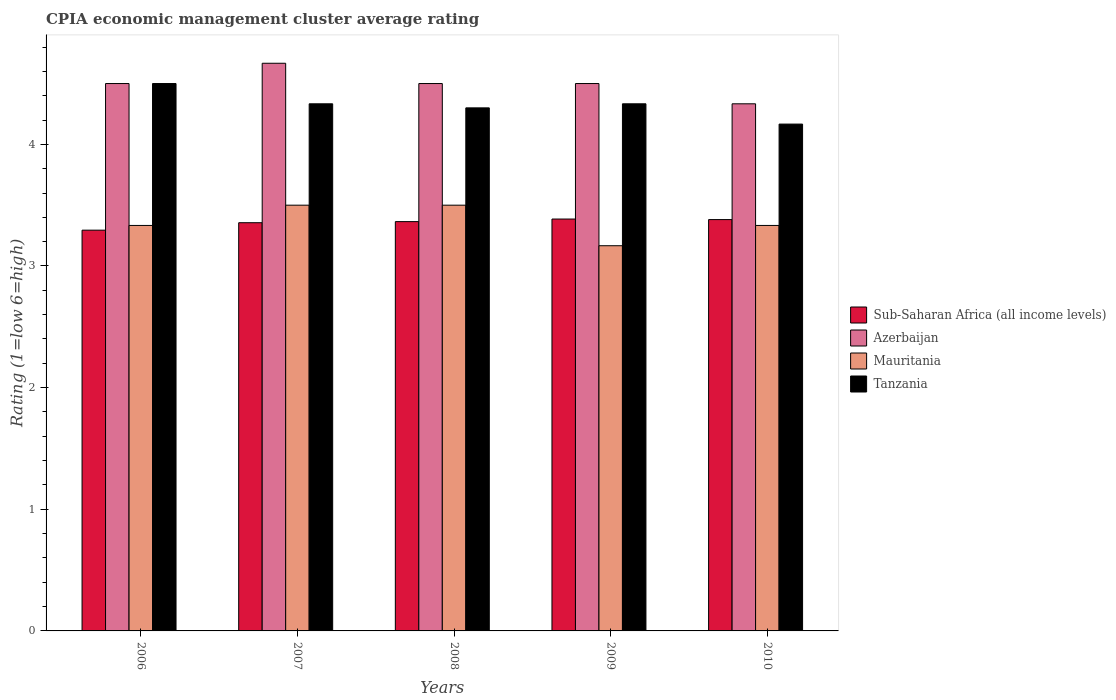How many groups of bars are there?
Ensure brevity in your answer.  5. Are the number of bars per tick equal to the number of legend labels?
Make the answer very short. Yes. How many bars are there on the 5th tick from the right?
Your response must be concise. 4. What is the label of the 5th group of bars from the left?
Make the answer very short. 2010. What is the CPIA rating in Sub-Saharan Africa (all income levels) in 2006?
Offer a terse response. 3.29. Across all years, what is the maximum CPIA rating in Mauritania?
Make the answer very short. 3.5. Across all years, what is the minimum CPIA rating in Mauritania?
Provide a succinct answer. 3.17. In which year was the CPIA rating in Mauritania maximum?
Keep it short and to the point. 2007. In which year was the CPIA rating in Azerbaijan minimum?
Your response must be concise. 2010. What is the total CPIA rating in Mauritania in the graph?
Offer a terse response. 16.83. What is the difference between the CPIA rating in Tanzania in 2006 and that in 2007?
Keep it short and to the point. 0.17. What is the difference between the CPIA rating in Tanzania in 2007 and the CPIA rating in Sub-Saharan Africa (all income levels) in 2008?
Give a very brief answer. 0.97. In the year 2009, what is the difference between the CPIA rating in Azerbaijan and CPIA rating in Tanzania?
Offer a very short reply. 0.17. In how many years, is the CPIA rating in Mauritania greater than 3.2?
Keep it short and to the point. 4. What is the ratio of the CPIA rating in Mauritania in 2007 to that in 2008?
Make the answer very short. 1. Is the CPIA rating in Azerbaijan in 2007 less than that in 2010?
Make the answer very short. No. What is the difference between the highest and the second highest CPIA rating in Tanzania?
Your response must be concise. 0.17. What is the difference between the highest and the lowest CPIA rating in Tanzania?
Provide a succinct answer. 0.33. What does the 1st bar from the left in 2007 represents?
Make the answer very short. Sub-Saharan Africa (all income levels). What does the 4th bar from the right in 2007 represents?
Your response must be concise. Sub-Saharan Africa (all income levels). How many bars are there?
Provide a short and direct response. 20. Are all the bars in the graph horizontal?
Make the answer very short. No. What is the difference between two consecutive major ticks on the Y-axis?
Offer a terse response. 1. Are the values on the major ticks of Y-axis written in scientific E-notation?
Provide a short and direct response. No. How are the legend labels stacked?
Ensure brevity in your answer.  Vertical. What is the title of the graph?
Make the answer very short. CPIA economic management cluster average rating. What is the label or title of the X-axis?
Provide a succinct answer. Years. What is the Rating (1=low 6=high) in Sub-Saharan Africa (all income levels) in 2006?
Provide a short and direct response. 3.29. What is the Rating (1=low 6=high) of Azerbaijan in 2006?
Keep it short and to the point. 4.5. What is the Rating (1=low 6=high) of Mauritania in 2006?
Give a very brief answer. 3.33. What is the Rating (1=low 6=high) of Sub-Saharan Africa (all income levels) in 2007?
Keep it short and to the point. 3.36. What is the Rating (1=low 6=high) in Azerbaijan in 2007?
Offer a very short reply. 4.67. What is the Rating (1=low 6=high) in Mauritania in 2007?
Your response must be concise. 3.5. What is the Rating (1=low 6=high) in Tanzania in 2007?
Keep it short and to the point. 4.33. What is the Rating (1=low 6=high) in Sub-Saharan Africa (all income levels) in 2008?
Offer a very short reply. 3.36. What is the Rating (1=low 6=high) of Azerbaijan in 2008?
Make the answer very short. 4.5. What is the Rating (1=low 6=high) of Mauritania in 2008?
Give a very brief answer. 3.5. What is the Rating (1=low 6=high) of Tanzania in 2008?
Offer a very short reply. 4.3. What is the Rating (1=low 6=high) of Sub-Saharan Africa (all income levels) in 2009?
Offer a terse response. 3.39. What is the Rating (1=low 6=high) in Mauritania in 2009?
Provide a succinct answer. 3.17. What is the Rating (1=low 6=high) of Tanzania in 2009?
Your response must be concise. 4.33. What is the Rating (1=low 6=high) in Sub-Saharan Africa (all income levels) in 2010?
Offer a very short reply. 3.38. What is the Rating (1=low 6=high) of Azerbaijan in 2010?
Give a very brief answer. 4.33. What is the Rating (1=low 6=high) in Mauritania in 2010?
Provide a succinct answer. 3.33. What is the Rating (1=low 6=high) in Tanzania in 2010?
Provide a short and direct response. 4.17. Across all years, what is the maximum Rating (1=low 6=high) in Sub-Saharan Africa (all income levels)?
Provide a succinct answer. 3.39. Across all years, what is the maximum Rating (1=low 6=high) of Azerbaijan?
Your answer should be compact. 4.67. Across all years, what is the maximum Rating (1=low 6=high) of Tanzania?
Provide a succinct answer. 4.5. Across all years, what is the minimum Rating (1=low 6=high) of Sub-Saharan Africa (all income levels)?
Your answer should be very brief. 3.29. Across all years, what is the minimum Rating (1=low 6=high) in Azerbaijan?
Make the answer very short. 4.33. Across all years, what is the minimum Rating (1=low 6=high) in Mauritania?
Your answer should be compact. 3.17. Across all years, what is the minimum Rating (1=low 6=high) in Tanzania?
Provide a succinct answer. 4.17. What is the total Rating (1=low 6=high) in Sub-Saharan Africa (all income levels) in the graph?
Offer a terse response. 16.78. What is the total Rating (1=low 6=high) of Azerbaijan in the graph?
Give a very brief answer. 22.5. What is the total Rating (1=low 6=high) of Mauritania in the graph?
Keep it short and to the point. 16.83. What is the total Rating (1=low 6=high) in Tanzania in the graph?
Provide a short and direct response. 21.63. What is the difference between the Rating (1=low 6=high) of Sub-Saharan Africa (all income levels) in 2006 and that in 2007?
Give a very brief answer. -0.06. What is the difference between the Rating (1=low 6=high) of Azerbaijan in 2006 and that in 2007?
Your answer should be compact. -0.17. What is the difference between the Rating (1=low 6=high) in Sub-Saharan Africa (all income levels) in 2006 and that in 2008?
Your response must be concise. -0.07. What is the difference between the Rating (1=low 6=high) of Sub-Saharan Africa (all income levels) in 2006 and that in 2009?
Ensure brevity in your answer.  -0.09. What is the difference between the Rating (1=low 6=high) in Tanzania in 2006 and that in 2009?
Your answer should be very brief. 0.17. What is the difference between the Rating (1=low 6=high) of Sub-Saharan Africa (all income levels) in 2006 and that in 2010?
Provide a short and direct response. -0.09. What is the difference between the Rating (1=low 6=high) in Tanzania in 2006 and that in 2010?
Ensure brevity in your answer.  0.33. What is the difference between the Rating (1=low 6=high) of Sub-Saharan Africa (all income levels) in 2007 and that in 2008?
Keep it short and to the point. -0.01. What is the difference between the Rating (1=low 6=high) in Azerbaijan in 2007 and that in 2008?
Make the answer very short. 0.17. What is the difference between the Rating (1=low 6=high) in Mauritania in 2007 and that in 2008?
Keep it short and to the point. 0. What is the difference between the Rating (1=low 6=high) of Tanzania in 2007 and that in 2008?
Ensure brevity in your answer.  0.03. What is the difference between the Rating (1=low 6=high) of Sub-Saharan Africa (all income levels) in 2007 and that in 2009?
Keep it short and to the point. -0.03. What is the difference between the Rating (1=low 6=high) in Sub-Saharan Africa (all income levels) in 2007 and that in 2010?
Provide a succinct answer. -0.03. What is the difference between the Rating (1=low 6=high) in Azerbaijan in 2007 and that in 2010?
Offer a terse response. 0.33. What is the difference between the Rating (1=low 6=high) of Mauritania in 2007 and that in 2010?
Make the answer very short. 0.17. What is the difference between the Rating (1=low 6=high) of Tanzania in 2007 and that in 2010?
Your answer should be compact. 0.17. What is the difference between the Rating (1=low 6=high) in Sub-Saharan Africa (all income levels) in 2008 and that in 2009?
Your answer should be compact. -0.02. What is the difference between the Rating (1=low 6=high) in Azerbaijan in 2008 and that in 2009?
Ensure brevity in your answer.  0. What is the difference between the Rating (1=low 6=high) of Tanzania in 2008 and that in 2009?
Provide a short and direct response. -0.03. What is the difference between the Rating (1=low 6=high) in Sub-Saharan Africa (all income levels) in 2008 and that in 2010?
Offer a terse response. -0.02. What is the difference between the Rating (1=low 6=high) in Tanzania in 2008 and that in 2010?
Your answer should be very brief. 0.13. What is the difference between the Rating (1=low 6=high) of Sub-Saharan Africa (all income levels) in 2009 and that in 2010?
Offer a terse response. 0. What is the difference between the Rating (1=low 6=high) in Azerbaijan in 2009 and that in 2010?
Offer a terse response. 0.17. What is the difference between the Rating (1=low 6=high) of Mauritania in 2009 and that in 2010?
Make the answer very short. -0.17. What is the difference between the Rating (1=low 6=high) of Sub-Saharan Africa (all income levels) in 2006 and the Rating (1=low 6=high) of Azerbaijan in 2007?
Your response must be concise. -1.37. What is the difference between the Rating (1=low 6=high) of Sub-Saharan Africa (all income levels) in 2006 and the Rating (1=low 6=high) of Mauritania in 2007?
Your response must be concise. -0.21. What is the difference between the Rating (1=low 6=high) in Sub-Saharan Africa (all income levels) in 2006 and the Rating (1=low 6=high) in Tanzania in 2007?
Your answer should be compact. -1.04. What is the difference between the Rating (1=low 6=high) in Azerbaijan in 2006 and the Rating (1=low 6=high) in Mauritania in 2007?
Your answer should be compact. 1. What is the difference between the Rating (1=low 6=high) in Azerbaijan in 2006 and the Rating (1=low 6=high) in Tanzania in 2007?
Provide a short and direct response. 0.17. What is the difference between the Rating (1=low 6=high) of Mauritania in 2006 and the Rating (1=low 6=high) of Tanzania in 2007?
Keep it short and to the point. -1. What is the difference between the Rating (1=low 6=high) of Sub-Saharan Africa (all income levels) in 2006 and the Rating (1=low 6=high) of Azerbaijan in 2008?
Keep it short and to the point. -1.21. What is the difference between the Rating (1=low 6=high) in Sub-Saharan Africa (all income levels) in 2006 and the Rating (1=low 6=high) in Mauritania in 2008?
Give a very brief answer. -0.21. What is the difference between the Rating (1=low 6=high) in Sub-Saharan Africa (all income levels) in 2006 and the Rating (1=low 6=high) in Tanzania in 2008?
Your response must be concise. -1.01. What is the difference between the Rating (1=low 6=high) in Mauritania in 2006 and the Rating (1=low 6=high) in Tanzania in 2008?
Keep it short and to the point. -0.97. What is the difference between the Rating (1=low 6=high) of Sub-Saharan Africa (all income levels) in 2006 and the Rating (1=low 6=high) of Azerbaijan in 2009?
Your response must be concise. -1.21. What is the difference between the Rating (1=low 6=high) of Sub-Saharan Africa (all income levels) in 2006 and the Rating (1=low 6=high) of Mauritania in 2009?
Make the answer very short. 0.13. What is the difference between the Rating (1=low 6=high) of Sub-Saharan Africa (all income levels) in 2006 and the Rating (1=low 6=high) of Tanzania in 2009?
Provide a short and direct response. -1.04. What is the difference between the Rating (1=low 6=high) in Azerbaijan in 2006 and the Rating (1=low 6=high) in Mauritania in 2009?
Your response must be concise. 1.33. What is the difference between the Rating (1=low 6=high) of Azerbaijan in 2006 and the Rating (1=low 6=high) of Tanzania in 2009?
Make the answer very short. 0.17. What is the difference between the Rating (1=low 6=high) in Sub-Saharan Africa (all income levels) in 2006 and the Rating (1=low 6=high) in Azerbaijan in 2010?
Offer a terse response. -1.04. What is the difference between the Rating (1=low 6=high) of Sub-Saharan Africa (all income levels) in 2006 and the Rating (1=low 6=high) of Mauritania in 2010?
Keep it short and to the point. -0.04. What is the difference between the Rating (1=low 6=high) in Sub-Saharan Africa (all income levels) in 2006 and the Rating (1=low 6=high) in Tanzania in 2010?
Provide a succinct answer. -0.87. What is the difference between the Rating (1=low 6=high) in Azerbaijan in 2006 and the Rating (1=low 6=high) in Mauritania in 2010?
Make the answer very short. 1.17. What is the difference between the Rating (1=low 6=high) in Azerbaijan in 2006 and the Rating (1=low 6=high) in Tanzania in 2010?
Offer a terse response. 0.33. What is the difference between the Rating (1=low 6=high) of Sub-Saharan Africa (all income levels) in 2007 and the Rating (1=low 6=high) of Azerbaijan in 2008?
Ensure brevity in your answer.  -1.14. What is the difference between the Rating (1=low 6=high) in Sub-Saharan Africa (all income levels) in 2007 and the Rating (1=low 6=high) in Mauritania in 2008?
Offer a terse response. -0.14. What is the difference between the Rating (1=low 6=high) of Sub-Saharan Africa (all income levels) in 2007 and the Rating (1=low 6=high) of Tanzania in 2008?
Keep it short and to the point. -0.94. What is the difference between the Rating (1=low 6=high) in Azerbaijan in 2007 and the Rating (1=low 6=high) in Tanzania in 2008?
Give a very brief answer. 0.37. What is the difference between the Rating (1=low 6=high) of Mauritania in 2007 and the Rating (1=low 6=high) of Tanzania in 2008?
Your response must be concise. -0.8. What is the difference between the Rating (1=low 6=high) in Sub-Saharan Africa (all income levels) in 2007 and the Rating (1=low 6=high) in Azerbaijan in 2009?
Offer a very short reply. -1.14. What is the difference between the Rating (1=low 6=high) in Sub-Saharan Africa (all income levels) in 2007 and the Rating (1=low 6=high) in Mauritania in 2009?
Offer a terse response. 0.19. What is the difference between the Rating (1=low 6=high) of Sub-Saharan Africa (all income levels) in 2007 and the Rating (1=low 6=high) of Tanzania in 2009?
Provide a succinct answer. -0.98. What is the difference between the Rating (1=low 6=high) in Sub-Saharan Africa (all income levels) in 2007 and the Rating (1=low 6=high) in Azerbaijan in 2010?
Offer a very short reply. -0.98. What is the difference between the Rating (1=low 6=high) of Sub-Saharan Africa (all income levels) in 2007 and the Rating (1=low 6=high) of Mauritania in 2010?
Offer a very short reply. 0.02. What is the difference between the Rating (1=low 6=high) in Sub-Saharan Africa (all income levels) in 2007 and the Rating (1=low 6=high) in Tanzania in 2010?
Make the answer very short. -0.81. What is the difference between the Rating (1=low 6=high) of Azerbaijan in 2007 and the Rating (1=low 6=high) of Mauritania in 2010?
Make the answer very short. 1.33. What is the difference between the Rating (1=low 6=high) of Sub-Saharan Africa (all income levels) in 2008 and the Rating (1=low 6=high) of Azerbaijan in 2009?
Your answer should be compact. -1.14. What is the difference between the Rating (1=low 6=high) of Sub-Saharan Africa (all income levels) in 2008 and the Rating (1=low 6=high) of Mauritania in 2009?
Keep it short and to the point. 0.2. What is the difference between the Rating (1=low 6=high) of Sub-Saharan Africa (all income levels) in 2008 and the Rating (1=low 6=high) of Tanzania in 2009?
Your response must be concise. -0.97. What is the difference between the Rating (1=low 6=high) of Sub-Saharan Africa (all income levels) in 2008 and the Rating (1=low 6=high) of Azerbaijan in 2010?
Provide a short and direct response. -0.97. What is the difference between the Rating (1=low 6=high) of Sub-Saharan Africa (all income levels) in 2008 and the Rating (1=low 6=high) of Mauritania in 2010?
Offer a very short reply. 0.03. What is the difference between the Rating (1=low 6=high) in Sub-Saharan Africa (all income levels) in 2008 and the Rating (1=low 6=high) in Tanzania in 2010?
Offer a terse response. -0.8. What is the difference between the Rating (1=low 6=high) in Azerbaijan in 2008 and the Rating (1=low 6=high) in Mauritania in 2010?
Keep it short and to the point. 1.17. What is the difference between the Rating (1=low 6=high) in Azerbaijan in 2008 and the Rating (1=low 6=high) in Tanzania in 2010?
Give a very brief answer. 0.33. What is the difference between the Rating (1=low 6=high) in Sub-Saharan Africa (all income levels) in 2009 and the Rating (1=low 6=high) in Azerbaijan in 2010?
Ensure brevity in your answer.  -0.95. What is the difference between the Rating (1=low 6=high) in Sub-Saharan Africa (all income levels) in 2009 and the Rating (1=low 6=high) in Mauritania in 2010?
Your answer should be compact. 0.05. What is the difference between the Rating (1=low 6=high) in Sub-Saharan Africa (all income levels) in 2009 and the Rating (1=low 6=high) in Tanzania in 2010?
Ensure brevity in your answer.  -0.78. What is the difference between the Rating (1=low 6=high) in Azerbaijan in 2009 and the Rating (1=low 6=high) in Mauritania in 2010?
Your answer should be compact. 1.17. What is the difference between the Rating (1=low 6=high) of Azerbaijan in 2009 and the Rating (1=low 6=high) of Tanzania in 2010?
Your response must be concise. 0.33. What is the average Rating (1=low 6=high) of Sub-Saharan Africa (all income levels) per year?
Your answer should be very brief. 3.36. What is the average Rating (1=low 6=high) in Mauritania per year?
Your answer should be compact. 3.37. What is the average Rating (1=low 6=high) of Tanzania per year?
Your answer should be very brief. 4.33. In the year 2006, what is the difference between the Rating (1=low 6=high) in Sub-Saharan Africa (all income levels) and Rating (1=low 6=high) in Azerbaijan?
Provide a succinct answer. -1.21. In the year 2006, what is the difference between the Rating (1=low 6=high) in Sub-Saharan Africa (all income levels) and Rating (1=low 6=high) in Mauritania?
Your answer should be compact. -0.04. In the year 2006, what is the difference between the Rating (1=low 6=high) of Sub-Saharan Africa (all income levels) and Rating (1=low 6=high) of Tanzania?
Your response must be concise. -1.21. In the year 2006, what is the difference between the Rating (1=low 6=high) in Azerbaijan and Rating (1=low 6=high) in Tanzania?
Offer a terse response. 0. In the year 2006, what is the difference between the Rating (1=low 6=high) of Mauritania and Rating (1=low 6=high) of Tanzania?
Offer a very short reply. -1.17. In the year 2007, what is the difference between the Rating (1=low 6=high) in Sub-Saharan Africa (all income levels) and Rating (1=low 6=high) in Azerbaijan?
Offer a very short reply. -1.31. In the year 2007, what is the difference between the Rating (1=low 6=high) of Sub-Saharan Africa (all income levels) and Rating (1=low 6=high) of Mauritania?
Provide a short and direct response. -0.14. In the year 2007, what is the difference between the Rating (1=low 6=high) of Sub-Saharan Africa (all income levels) and Rating (1=low 6=high) of Tanzania?
Provide a short and direct response. -0.98. In the year 2007, what is the difference between the Rating (1=low 6=high) of Mauritania and Rating (1=low 6=high) of Tanzania?
Your answer should be compact. -0.83. In the year 2008, what is the difference between the Rating (1=low 6=high) of Sub-Saharan Africa (all income levels) and Rating (1=low 6=high) of Azerbaijan?
Your response must be concise. -1.14. In the year 2008, what is the difference between the Rating (1=low 6=high) of Sub-Saharan Africa (all income levels) and Rating (1=low 6=high) of Mauritania?
Provide a succinct answer. -0.14. In the year 2008, what is the difference between the Rating (1=low 6=high) in Sub-Saharan Africa (all income levels) and Rating (1=low 6=high) in Tanzania?
Your answer should be very brief. -0.94. In the year 2008, what is the difference between the Rating (1=low 6=high) of Mauritania and Rating (1=low 6=high) of Tanzania?
Provide a short and direct response. -0.8. In the year 2009, what is the difference between the Rating (1=low 6=high) of Sub-Saharan Africa (all income levels) and Rating (1=low 6=high) of Azerbaijan?
Keep it short and to the point. -1.11. In the year 2009, what is the difference between the Rating (1=low 6=high) in Sub-Saharan Africa (all income levels) and Rating (1=low 6=high) in Mauritania?
Make the answer very short. 0.22. In the year 2009, what is the difference between the Rating (1=low 6=high) in Sub-Saharan Africa (all income levels) and Rating (1=low 6=high) in Tanzania?
Give a very brief answer. -0.95. In the year 2009, what is the difference between the Rating (1=low 6=high) of Azerbaijan and Rating (1=low 6=high) of Tanzania?
Make the answer very short. 0.17. In the year 2009, what is the difference between the Rating (1=low 6=high) in Mauritania and Rating (1=low 6=high) in Tanzania?
Keep it short and to the point. -1.17. In the year 2010, what is the difference between the Rating (1=low 6=high) of Sub-Saharan Africa (all income levels) and Rating (1=low 6=high) of Azerbaijan?
Your answer should be compact. -0.95. In the year 2010, what is the difference between the Rating (1=low 6=high) of Sub-Saharan Africa (all income levels) and Rating (1=low 6=high) of Mauritania?
Offer a very short reply. 0.05. In the year 2010, what is the difference between the Rating (1=low 6=high) of Sub-Saharan Africa (all income levels) and Rating (1=low 6=high) of Tanzania?
Ensure brevity in your answer.  -0.79. In the year 2010, what is the difference between the Rating (1=low 6=high) of Azerbaijan and Rating (1=low 6=high) of Mauritania?
Make the answer very short. 1. In the year 2010, what is the difference between the Rating (1=low 6=high) in Azerbaijan and Rating (1=low 6=high) in Tanzania?
Ensure brevity in your answer.  0.17. In the year 2010, what is the difference between the Rating (1=low 6=high) in Mauritania and Rating (1=low 6=high) in Tanzania?
Make the answer very short. -0.83. What is the ratio of the Rating (1=low 6=high) of Sub-Saharan Africa (all income levels) in 2006 to that in 2007?
Make the answer very short. 0.98. What is the ratio of the Rating (1=low 6=high) of Azerbaijan in 2006 to that in 2007?
Offer a terse response. 0.96. What is the ratio of the Rating (1=low 6=high) of Sub-Saharan Africa (all income levels) in 2006 to that in 2008?
Your answer should be compact. 0.98. What is the ratio of the Rating (1=low 6=high) in Tanzania in 2006 to that in 2008?
Provide a succinct answer. 1.05. What is the ratio of the Rating (1=low 6=high) of Sub-Saharan Africa (all income levels) in 2006 to that in 2009?
Your answer should be very brief. 0.97. What is the ratio of the Rating (1=low 6=high) in Azerbaijan in 2006 to that in 2009?
Your answer should be very brief. 1. What is the ratio of the Rating (1=low 6=high) in Mauritania in 2006 to that in 2009?
Your answer should be compact. 1.05. What is the ratio of the Rating (1=low 6=high) of Tanzania in 2006 to that in 2009?
Ensure brevity in your answer.  1.04. What is the ratio of the Rating (1=low 6=high) in Sub-Saharan Africa (all income levels) in 2006 to that in 2010?
Offer a terse response. 0.97. What is the ratio of the Rating (1=low 6=high) of Azerbaijan in 2006 to that in 2010?
Offer a very short reply. 1.04. What is the ratio of the Rating (1=low 6=high) of Sub-Saharan Africa (all income levels) in 2007 to that in 2008?
Make the answer very short. 1. What is the ratio of the Rating (1=low 6=high) of Mauritania in 2007 to that in 2008?
Provide a short and direct response. 1. What is the ratio of the Rating (1=low 6=high) of Sub-Saharan Africa (all income levels) in 2007 to that in 2009?
Provide a succinct answer. 0.99. What is the ratio of the Rating (1=low 6=high) in Azerbaijan in 2007 to that in 2009?
Your answer should be very brief. 1.04. What is the ratio of the Rating (1=low 6=high) in Mauritania in 2007 to that in 2009?
Your answer should be very brief. 1.11. What is the ratio of the Rating (1=low 6=high) of Tanzania in 2007 to that in 2009?
Your response must be concise. 1. What is the ratio of the Rating (1=low 6=high) of Sub-Saharan Africa (all income levels) in 2007 to that in 2010?
Keep it short and to the point. 0.99. What is the ratio of the Rating (1=low 6=high) of Azerbaijan in 2007 to that in 2010?
Offer a very short reply. 1.08. What is the ratio of the Rating (1=low 6=high) in Mauritania in 2008 to that in 2009?
Provide a short and direct response. 1.11. What is the ratio of the Rating (1=low 6=high) of Tanzania in 2008 to that in 2010?
Your answer should be compact. 1.03. What is the ratio of the Rating (1=low 6=high) in Sub-Saharan Africa (all income levels) in 2009 to that in 2010?
Keep it short and to the point. 1. What is the ratio of the Rating (1=low 6=high) in Azerbaijan in 2009 to that in 2010?
Provide a short and direct response. 1.04. What is the ratio of the Rating (1=low 6=high) of Mauritania in 2009 to that in 2010?
Provide a short and direct response. 0.95. What is the difference between the highest and the second highest Rating (1=low 6=high) in Sub-Saharan Africa (all income levels)?
Your answer should be very brief. 0. What is the difference between the highest and the second highest Rating (1=low 6=high) of Azerbaijan?
Your answer should be very brief. 0.17. What is the difference between the highest and the second highest Rating (1=low 6=high) in Mauritania?
Your answer should be compact. 0. What is the difference between the highest and the lowest Rating (1=low 6=high) in Sub-Saharan Africa (all income levels)?
Provide a short and direct response. 0.09. What is the difference between the highest and the lowest Rating (1=low 6=high) in Tanzania?
Your answer should be compact. 0.33. 